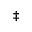Convert formula to latex. <formula><loc_0><loc_0><loc_500><loc_500>\ddagger</formula> 